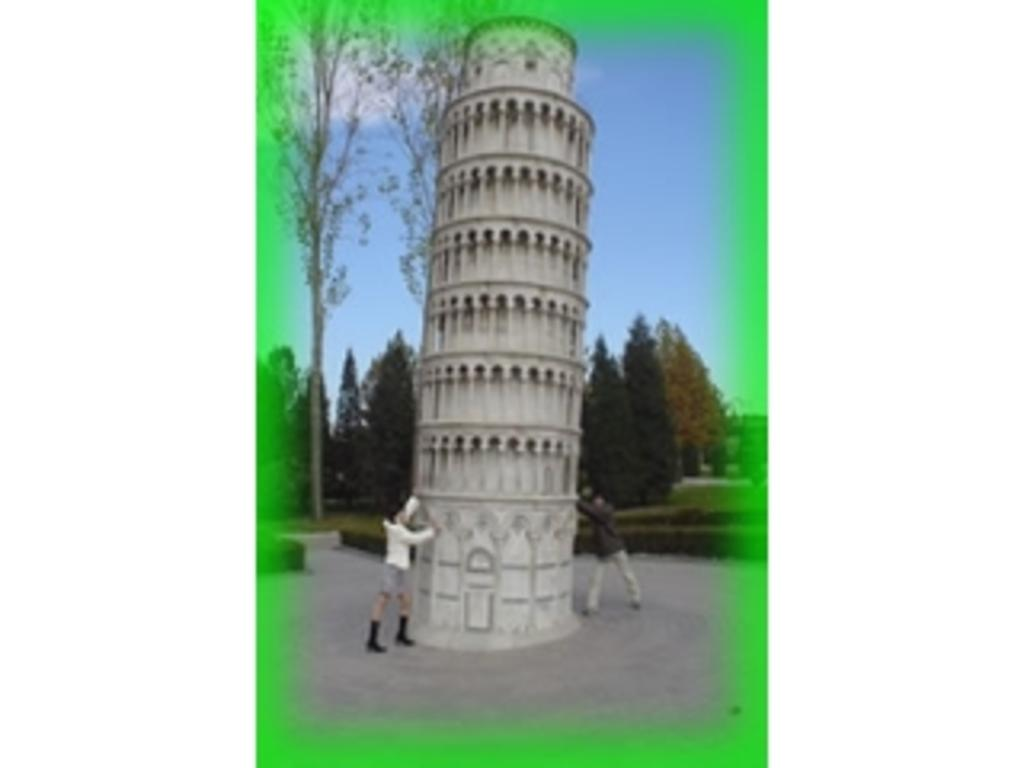What is the main structure in the image? There is a tower in the image. What are the two persons doing in the image? The two persons are touching the tower. What type of vegetation can be seen in the background of the image? There are trees in the background of the image. What part of the natural environment is visible in the image? The sky is visible in the background of the image. What type of foot can be seen on the tower in the image? There is no foot present on the tower in the image. Who is the manager of the tower in the image? There is no mention of a manager or any person associated with the tower in the image. 